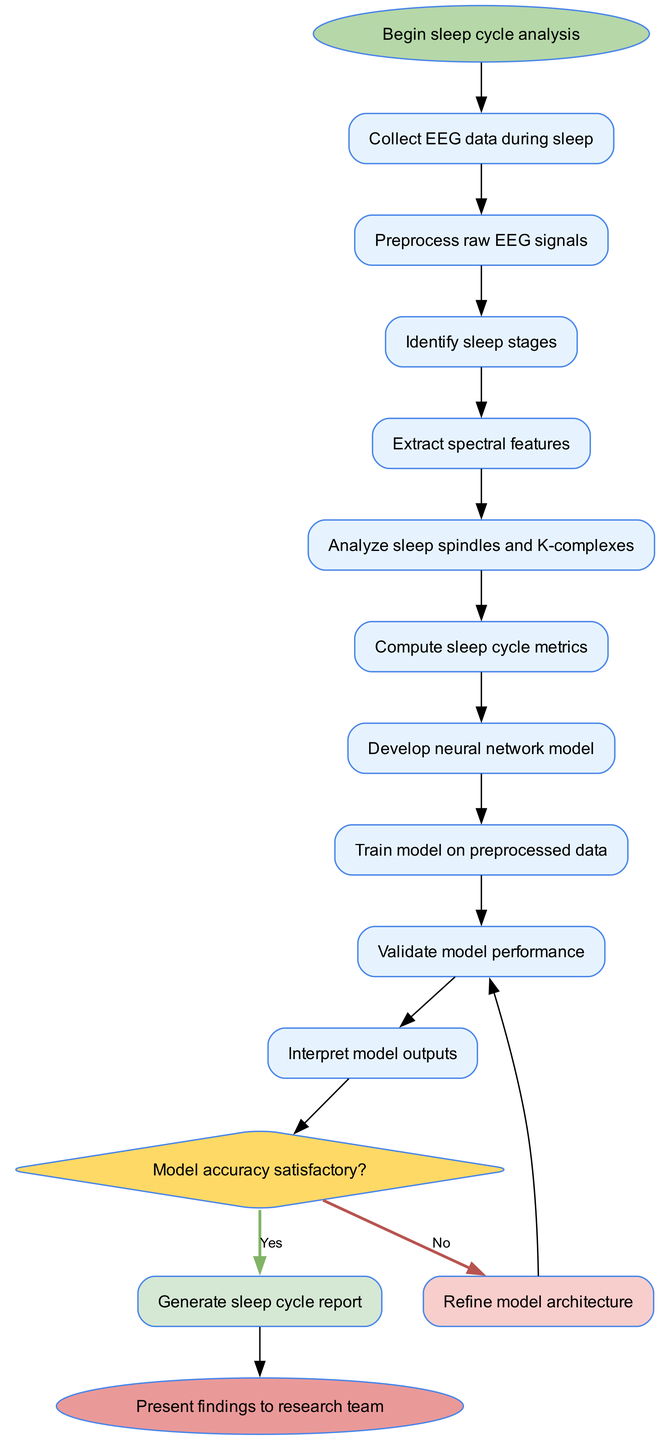What is the first activity in the sleep cycle analysis? The first activity is clearly indicated in the diagram as "Collect EEG data during sleep," which is connected directly to the start node.
Answer: Collect EEG data during sleep How many activities are there in the analysis process? By counting the nodes labeled as activities between the start and end nodes, we find there are ten activities listed in the diagram.
Answer: Ten What happens if the model accuracy is satisfactory? The diagram shows that if the model accuracy is satisfactory, the flow proceeds to the node "Generate sleep cycle report," which confirms the outcome of the decision node.
Answer: Generate sleep cycle report What is the last step before presenting findings? The last step before presenting findings is indicated as "Interpret model outputs," which is the activity that directly precedes the end node in the diagram.
Answer: Interpret model outputs If the model accuracy is not satisfactory, to which activity does the flow return? The diagram specifies that if the model accuracy is not satisfactory, the flow loops back to "Refine model architecture," from the decision node marked 'No.'
Answer: Refine model architecture What is the shape of the decision node? The decision node is depicted as a diamond shape in the diagram, which is a standard representation for decision points in activity diagrams.
Answer: Diamond What is the relationship between "Analyze sleep spindles and K-complexes" and "Compute sleep cycle metrics"? The relationship is sequential; "Analyze sleep spindles and K-complexes" feeds into the next activity "Compute sleep cycle metrics," with a directed edge connecting the two.
Answer: Sequential How many decision nodes are present in the diagram? The diagram contains one decision node, identified by the condition regarding the model's accuracy.
Answer: One What is the starting point of the sleep cycle analysis? The starting point is mentioned explicitly as "Begin sleep cycle analysis," serving as the origin node for this workflow.
Answer: Begin sleep cycle analysis 